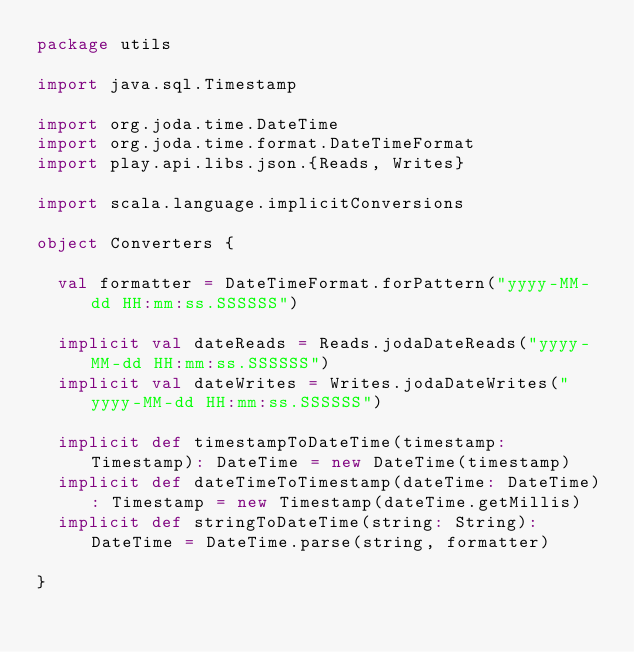<code> <loc_0><loc_0><loc_500><loc_500><_Scala_>package utils

import java.sql.Timestamp

import org.joda.time.DateTime
import org.joda.time.format.DateTimeFormat
import play.api.libs.json.{Reads, Writes}

import scala.language.implicitConversions

object Converters {

	val formatter = DateTimeFormat.forPattern("yyyy-MM-dd HH:mm:ss.SSSSSS")

	implicit val dateReads = Reads.jodaDateReads("yyyy-MM-dd HH:mm:ss.SSSSSS")
	implicit val dateWrites = Writes.jodaDateWrites("yyyy-MM-dd HH:mm:ss.SSSSSS")

	implicit def timestampToDateTime(timestamp: Timestamp): DateTime = new DateTime(timestamp)
	implicit def dateTimeToTimestamp(dateTime: DateTime): Timestamp = new Timestamp(dateTime.getMillis)
	implicit def stringToDateTime(string: String): DateTime = DateTime.parse(string, formatter)

}</code> 